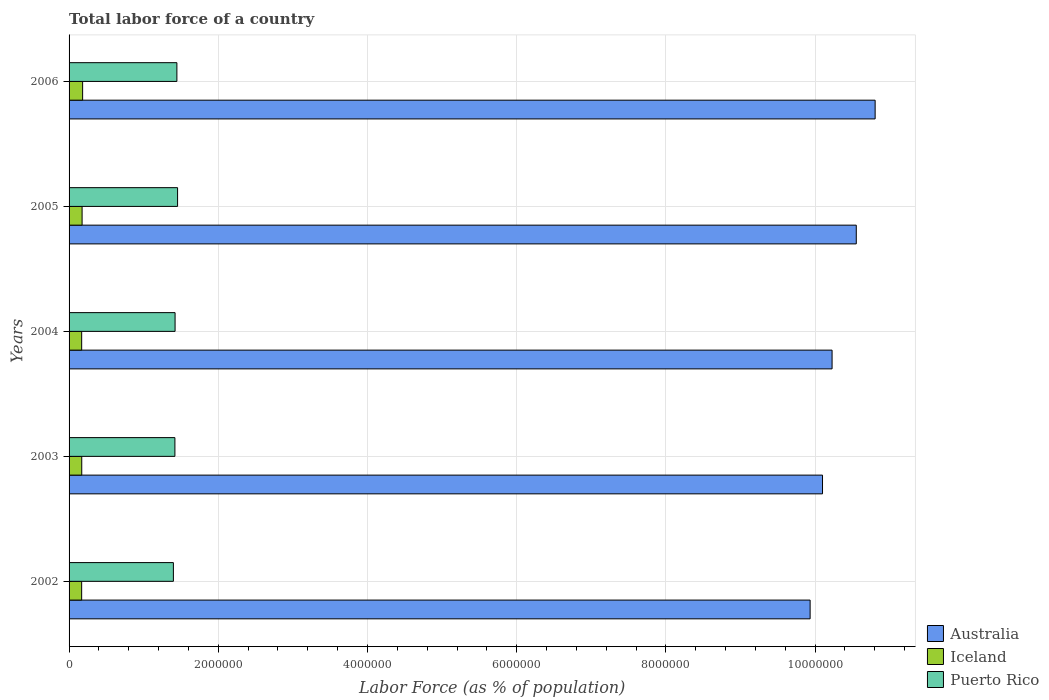How many different coloured bars are there?
Provide a short and direct response. 3. How many groups of bars are there?
Your answer should be very brief. 5. Are the number of bars per tick equal to the number of legend labels?
Give a very brief answer. Yes. How many bars are there on the 4th tick from the bottom?
Your answer should be very brief. 3. In how many cases, is the number of bars for a given year not equal to the number of legend labels?
Offer a terse response. 0. What is the percentage of labor force in Australia in 2004?
Provide a succinct answer. 1.02e+07. Across all years, what is the maximum percentage of labor force in Australia?
Give a very brief answer. 1.08e+07. Across all years, what is the minimum percentage of labor force in Iceland?
Provide a succinct answer. 1.69e+05. In which year was the percentage of labor force in Puerto Rico maximum?
Your response must be concise. 2005. What is the total percentage of labor force in Puerto Rico in the graph?
Your response must be concise. 7.14e+06. What is the difference between the percentage of labor force in Iceland in 2004 and that in 2006?
Your answer should be very brief. -1.29e+04. What is the difference between the percentage of labor force in Puerto Rico in 2005 and the percentage of labor force in Iceland in 2002?
Ensure brevity in your answer.  1.29e+06. What is the average percentage of labor force in Puerto Rico per year?
Your answer should be very brief. 1.43e+06. In the year 2004, what is the difference between the percentage of labor force in Iceland and percentage of labor force in Australia?
Your answer should be compact. -1.01e+07. In how many years, is the percentage of labor force in Iceland greater than 8800000 %?
Offer a terse response. 0. What is the ratio of the percentage of labor force in Puerto Rico in 2004 to that in 2005?
Your answer should be very brief. 0.98. Is the percentage of labor force in Australia in 2003 less than that in 2004?
Offer a very short reply. Yes. What is the difference between the highest and the second highest percentage of labor force in Australia?
Ensure brevity in your answer.  2.53e+05. What is the difference between the highest and the lowest percentage of labor force in Australia?
Your answer should be very brief. 8.71e+05. In how many years, is the percentage of labor force in Puerto Rico greater than the average percentage of labor force in Puerto Rico taken over all years?
Offer a very short reply. 2. What does the 1st bar from the top in 2005 represents?
Provide a succinct answer. Puerto Rico. What does the 3rd bar from the bottom in 2002 represents?
Keep it short and to the point. Puerto Rico. How many years are there in the graph?
Your answer should be very brief. 5. What is the difference between two consecutive major ticks on the X-axis?
Provide a succinct answer. 2.00e+06. Are the values on the major ticks of X-axis written in scientific E-notation?
Ensure brevity in your answer.  No. Where does the legend appear in the graph?
Provide a succinct answer. Bottom right. How are the legend labels stacked?
Provide a short and direct response. Vertical. What is the title of the graph?
Provide a succinct answer. Total labor force of a country. Does "United Kingdom" appear as one of the legend labels in the graph?
Offer a terse response. No. What is the label or title of the X-axis?
Offer a very short reply. Labor Force (as % of population). What is the label or title of the Y-axis?
Ensure brevity in your answer.  Years. What is the Labor Force (as % of population) of Australia in 2002?
Provide a succinct answer. 9.93e+06. What is the Labor Force (as % of population) of Iceland in 2002?
Your answer should be very brief. 1.69e+05. What is the Labor Force (as % of population) of Puerto Rico in 2002?
Make the answer very short. 1.40e+06. What is the Labor Force (as % of population) of Australia in 2003?
Offer a terse response. 1.01e+07. What is the Labor Force (as % of population) of Iceland in 2003?
Keep it short and to the point. 1.70e+05. What is the Labor Force (as % of population) of Puerto Rico in 2003?
Make the answer very short. 1.42e+06. What is the Labor Force (as % of population) in Australia in 2004?
Give a very brief answer. 1.02e+07. What is the Labor Force (as % of population) of Iceland in 2004?
Provide a short and direct response. 1.69e+05. What is the Labor Force (as % of population) of Puerto Rico in 2004?
Make the answer very short. 1.42e+06. What is the Labor Force (as % of population) of Australia in 2005?
Ensure brevity in your answer.  1.06e+07. What is the Labor Force (as % of population) in Iceland in 2005?
Your answer should be compact. 1.75e+05. What is the Labor Force (as % of population) in Puerto Rico in 2005?
Make the answer very short. 1.45e+06. What is the Labor Force (as % of population) of Australia in 2006?
Offer a terse response. 1.08e+07. What is the Labor Force (as % of population) in Iceland in 2006?
Give a very brief answer. 1.82e+05. What is the Labor Force (as % of population) in Puerto Rico in 2006?
Keep it short and to the point. 1.45e+06. Across all years, what is the maximum Labor Force (as % of population) in Australia?
Your answer should be very brief. 1.08e+07. Across all years, what is the maximum Labor Force (as % of population) of Iceland?
Your answer should be compact. 1.82e+05. Across all years, what is the maximum Labor Force (as % of population) in Puerto Rico?
Offer a terse response. 1.45e+06. Across all years, what is the minimum Labor Force (as % of population) of Australia?
Ensure brevity in your answer.  9.93e+06. Across all years, what is the minimum Labor Force (as % of population) of Iceland?
Offer a very short reply. 1.69e+05. Across all years, what is the minimum Labor Force (as % of population) in Puerto Rico?
Your answer should be compact. 1.40e+06. What is the total Labor Force (as % of population) in Australia in the graph?
Keep it short and to the point. 5.16e+07. What is the total Labor Force (as % of population) in Iceland in the graph?
Provide a short and direct response. 8.64e+05. What is the total Labor Force (as % of population) of Puerto Rico in the graph?
Provide a short and direct response. 7.14e+06. What is the difference between the Labor Force (as % of population) of Australia in 2002 and that in 2003?
Your answer should be compact. -1.66e+05. What is the difference between the Labor Force (as % of population) of Iceland in 2002 and that in 2003?
Give a very brief answer. -1405. What is the difference between the Labor Force (as % of population) in Puerto Rico in 2002 and that in 2003?
Provide a short and direct response. -2.03e+04. What is the difference between the Labor Force (as % of population) of Australia in 2002 and that in 2004?
Provide a succinct answer. -2.94e+05. What is the difference between the Labor Force (as % of population) of Iceland in 2002 and that in 2004?
Offer a terse response. -228. What is the difference between the Labor Force (as % of population) of Puerto Rico in 2002 and that in 2004?
Your response must be concise. -2.27e+04. What is the difference between the Labor Force (as % of population) of Australia in 2002 and that in 2005?
Your answer should be very brief. -6.19e+05. What is the difference between the Labor Force (as % of population) of Iceland in 2002 and that in 2005?
Ensure brevity in your answer.  -6024. What is the difference between the Labor Force (as % of population) of Puerto Rico in 2002 and that in 2005?
Provide a short and direct response. -5.61e+04. What is the difference between the Labor Force (as % of population) in Australia in 2002 and that in 2006?
Give a very brief answer. -8.71e+05. What is the difference between the Labor Force (as % of population) in Iceland in 2002 and that in 2006?
Your answer should be very brief. -1.31e+04. What is the difference between the Labor Force (as % of population) of Puerto Rico in 2002 and that in 2006?
Provide a succinct answer. -4.69e+04. What is the difference between the Labor Force (as % of population) of Australia in 2003 and that in 2004?
Make the answer very short. -1.28e+05. What is the difference between the Labor Force (as % of population) in Iceland in 2003 and that in 2004?
Your answer should be compact. 1177. What is the difference between the Labor Force (as % of population) of Puerto Rico in 2003 and that in 2004?
Keep it short and to the point. -2427. What is the difference between the Labor Force (as % of population) in Australia in 2003 and that in 2005?
Keep it short and to the point. -4.53e+05. What is the difference between the Labor Force (as % of population) of Iceland in 2003 and that in 2005?
Give a very brief answer. -4619. What is the difference between the Labor Force (as % of population) in Puerto Rico in 2003 and that in 2005?
Make the answer very short. -3.58e+04. What is the difference between the Labor Force (as % of population) of Australia in 2003 and that in 2006?
Make the answer very short. -7.05e+05. What is the difference between the Labor Force (as % of population) in Iceland in 2003 and that in 2006?
Provide a short and direct response. -1.17e+04. What is the difference between the Labor Force (as % of population) of Puerto Rico in 2003 and that in 2006?
Provide a succinct answer. -2.66e+04. What is the difference between the Labor Force (as % of population) in Australia in 2004 and that in 2005?
Offer a terse response. -3.24e+05. What is the difference between the Labor Force (as % of population) of Iceland in 2004 and that in 2005?
Offer a very short reply. -5796. What is the difference between the Labor Force (as % of population) in Puerto Rico in 2004 and that in 2005?
Ensure brevity in your answer.  -3.34e+04. What is the difference between the Labor Force (as % of population) in Australia in 2004 and that in 2006?
Provide a succinct answer. -5.77e+05. What is the difference between the Labor Force (as % of population) of Iceland in 2004 and that in 2006?
Your answer should be compact. -1.29e+04. What is the difference between the Labor Force (as % of population) of Puerto Rico in 2004 and that in 2006?
Give a very brief answer. -2.42e+04. What is the difference between the Labor Force (as % of population) of Australia in 2005 and that in 2006?
Offer a terse response. -2.53e+05. What is the difference between the Labor Force (as % of population) in Iceland in 2005 and that in 2006?
Provide a short and direct response. -7066. What is the difference between the Labor Force (as % of population) of Puerto Rico in 2005 and that in 2006?
Offer a very short reply. 9212. What is the difference between the Labor Force (as % of population) in Australia in 2002 and the Labor Force (as % of population) in Iceland in 2003?
Provide a short and direct response. 9.76e+06. What is the difference between the Labor Force (as % of population) in Australia in 2002 and the Labor Force (as % of population) in Puerto Rico in 2003?
Make the answer very short. 8.51e+06. What is the difference between the Labor Force (as % of population) of Iceland in 2002 and the Labor Force (as % of population) of Puerto Rico in 2003?
Give a very brief answer. -1.25e+06. What is the difference between the Labor Force (as % of population) of Australia in 2002 and the Labor Force (as % of population) of Iceland in 2004?
Keep it short and to the point. 9.76e+06. What is the difference between the Labor Force (as % of population) of Australia in 2002 and the Labor Force (as % of population) of Puerto Rico in 2004?
Provide a short and direct response. 8.51e+06. What is the difference between the Labor Force (as % of population) of Iceland in 2002 and the Labor Force (as % of population) of Puerto Rico in 2004?
Your response must be concise. -1.25e+06. What is the difference between the Labor Force (as % of population) in Australia in 2002 and the Labor Force (as % of population) in Iceland in 2005?
Offer a very short reply. 9.76e+06. What is the difference between the Labor Force (as % of population) of Australia in 2002 and the Labor Force (as % of population) of Puerto Rico in 2005?
Provide a short and direct response. 8.48e+06. What is the difference between the Labor Force (as % of population) in Iceland in 2002 and the Labor Force (as % of population) in Puerto Rico in 2005?
Make the answer very short. -1.29e+06. What is the difference between the Labor Force (as % of population) of Australia in 2002 and the Labor Force (as % of population) of Iceland in 2006?
Offer a terse response. 9.75e+06. What is the difference between the Labor Force (as % of population) of Australia in 2002 and the Labor Force (as % of population) of Puerto Rico in 2006?
Make the answer very short. 8.49e+06. What is the difference between the Labor Force (as % of population) of Iceland in 2002 and the Labor Force (as % of population) of Puerto Rico in 2006?
Your response must be concise. -1.28e+06. What is the difference between the Labor Force (as % of population) of Australia in 2003 and the Labor Force (as % of population) of Iceland in 2004?
Provide a short and direct response. 9.93e+06. What is the difference between the Labor Force (as % of population) of Australia in 2003 and the Labor Force (as % of population) of Puerto Rico in 2004?
Your answer should be very brief. 8.68e+06. What is the difference between the Labor Force (as % of population) of Iceland in 2003 and the Labor Force (as % of population) of Puerto Rico in 2004?
Provide a succinct answer. -1.25e+06. What is the difference between the Labor Force (as % of population) in Australia in 2003 and the Labor Force (as % of population) in Iceland in 2005?
Your answer should be very brief. 9.92e+06. What is the difference between the Labor Force (as % of population) in Australia in 2003 and the Labor Force (as % of population) in Puerto Rico in 2005?
Ensure brevity in your answer.  8.64e+06. What is the difference between the Labor Force (as % of population) of Iceland in 2003 and the Labor Force (as % of population) of Puerto Rico in 2005?
Offer a terse response. -1.28e+06. What is the difference between the Labor Force (as % of population) of Australia in 2003 and the Labor Force (as % of population) of Iceland in 2006?
Offer a very short reply. 9.92e+06. What is the difference between the Labor Force (as % of population) of Australia in 2003 and the Labor Force (as % of population) of Puerto Rico in 2006?
Provide a succinct answer. 8.65e+06. What is the difference between the Labor Force (as % of population) in Iceland in 2003 and the Labor Force (as % of population) in Puerto Rico in 2006?
Provide a succinct answer. -1.28e+06. What is the difference between the Labor Force (as % of population) in Australia in 2004 and the Labor Force (as % of population) in Iceland in 2005?
Keep it short and to the point. 1.01e+07. What is the difference between the Labor Force (as % of population) of Australia in 2004 and the Labor Force (as % of population) of Puerto Rico in 2005?
Keep it short and to the point. 8.77e+06. What is the difference between the Labor Force (as % of population) of Iceland in 2004 and the Labor Force (as % of population) of Puerto Rico in 2005?
Provide a short and direct response. -1.29e+06. What is the difference between the Labor Force (as % of population) of Australia in 2004 and the Labor Force (as % of population) of Iceland in 2006?
Provide a succinct answer. 1.00e+07. What is the difference between the Labor Force (as % of population) of Australia in 2004 and the Labor Force (as % of population) of Puerto Rico in 2006?
Offer a terse response. 8.78e+06. What is the difference between the Labor Force (as % of population) of Iceland in 2004 and the Labor Force (as % of population) of Puerto Rico in 2006?
Your answer should be compact. -1.28e+06. What is the difference between the Labor Force (as % of population) of Australia in 2005 and the Labor Force (as % of population) of Iceland in 2006?
Make the answer very short. 1.04e+07. What is the difference between the Labor Force (as % of population) of Australia in 2005 and the Labor Force (as % of population) of Puerto Rico in 2006?
Offer a terse response. 9.11e+06. What is the difference between the Labor Force (as % of population) of Iceland in 2005 and the Labor Force (as % of population) of Puerto Rico in 2006?
Your answer should be very brief. -1.27e+06. What is the average Labor Force (as % of population) of Australia per year?
Your response must be concise. 1.03e+07. What is the average Labor Force (as % of population) of Iceland per year?
Make the answer very short. 1.73e+05. What is the average Labor Force (as % of population) of Puerto Rico per year?
Make the answer very short. 1.43e+06. In the year 2002, what is the difference between the Labor Force (as % of population) in Australia and Labor Force (as % of population) in Iceland?
Keep it short and to the point. 9.76e+06. In the year 2002, what is the difference between the Labor Force (as % of population) in Australia and Labor Force (as % of population) in Puerto Rico?
Your response must be concise. 8.53e+06. In the year 2002, what is the difference between the Labor Force (as % of population) of Iceland and Labor Force (as % of population) of Puerto Rico?
Your answer should be very brief. -1.23e+06. In the year 2003, what is the difference between the Labor Force (as % of population) in Australia and Labor Force (as % of population) in Iceland?
Your answer should be compact. 9.93e+06. In the year 2003, what is the difference between the Labor Force (as % of population) of Australia and Labor Force (as % of population) of Puerto Rico?
Offer a very short reply. 8.68e+06. In the year 2003, what is the difference between the Labor Force (as % of population) in Iceland and Labor Force (as % of population) in Puerto Rico?
Keep it short and to the point. -1.25e+06. In the year 2004, what is the difference between the Labor Force (as % of population) of Australia and Labor Force (as % of population) of Iceland?
Give a very brief answer. 1.01e+07. In the year 2004, what is the difference between the Labor Force (as % of population) of Australia and Labor Force (as % of population) of Puerto Rico?
Provide a short and direct response. 8.81e+06. In the year 2004, what is the difference between the Labor Force (as % of population) of Iceland and Labor Force (as % of population) of Puerto Rico?
Give a very brief answer. -1.25e+06. In the year 2005, what is the difference between the Labor Force (as % of population) in Australia and Labor Force (as % of population) in Iceland?
Offer a very short reply. 1.04e+07. In the year 2005, what is the difference between the Labor Force (as % of population) of Australia and Labor Force (as % of population) of Puerto Rico?
Give a very brief answer. 9.10e+06. In the year 2005, what is the difference between the Labor Force (as % of population) of Iceland and Labor Force (as % of population) of Puerto Rico?
Your response must be concise. -1.28e+06. In the year 2006, what is the difference between the Labor Force (as % of population) of Australia and Labor Force (as % of population) of Iceland?
Provide a short and direct response. 1.06e+07. In the year 2006, what is the difference between the Labor Force (as % of population) of Australia and Labor Force (as % of population) of Puerto Rico?
Offer a very short reply. 9.36e+06. In the year 2006, what is the difference between the Labor Force (as % of population) in Iceland and Labor Force (as % of population) in Puerto Rico?
Offer a very short reply. -1.26e+06. What is the ratio of the Labor Force (as % of population) of Australia in 2002 to that in 2003?
Offer a terse response. 0.98. What is the ratio of the Labor Force (as % of population) in Iceland in 2002 to that in 2003?
Make the answer very short. 0.99. What is the ratio of the Labor Force (as % of population) in Puerto Rico in 2002 to that in 2003?
Provide a succinct answer. 0.99. What is the ratio of the Labor Force (as % of population) in Australia in 2002 to that in 2004?
Offer a terse response. 0.97. What is the ratio of the Labor Force (as % of population) in Iceland in 2002 to that in 2004?
Offer a terse response. 1. What is the ratio of the Labor Force (as % of population) in Australia in 2002 to that in 2005?
Give a very brief answer. 0.94. What is the ratio of the Labor Force (as % of population) in Iceland in 2002 to that in 2005?
Offer a terse response. 0.97. What is the ratio of the Labor Force (as % of population) of Puerto Rico in 2002 to that in 2005?
Your answer should be compact. 0.96. What is the ratio of the Labor Force (as % of population) of Australia in 2002 to that in 2006?
Offer a very short reply. 0.92. What is the ratio of the Labor Force (as % of population) of Iceland in 2002 to that in 2006?
Provide a short and direct response. 0.93. What is the ratio of the Labor Force (as % of population) of Puerto Rico in 2002 to that in 2006?
Your answer should be very brief. 0.97. What is the ratio of the Labor Force (as % of population) in Australia in 2003 to that in 2004?
Give a very brief answer. 0.99. What is the ratio of the Labor Force (as % of population) in Puerto Rico in 2003 to that in 2004?
Provide a short and direct response. 1. What is the ratio of the Labor Force (as % of population) of Australia in 2003 to that in 2005?
Ensure brevity in your answer.  0.96. What is the ratio of the Labor Force (as % of population) of Iceland in 2003 to that in 2005?
Ensure brevity in your answer.  0.97. What is the ratio of the Labor Force (as % of population) in Puerto Rico in 2003 to that in 2005?
Provide a short and direct response. 0.98. What is the ratio of the Labor Force (as % of population) in Australia in 2003 to that in 2006?
Keep it short and to the point. 0.93. What is the ratio of the Labor Force (as % of population) of Iceland in 2003 to that in 2006?
Offer a very short reply. 0.94. What is the ratio of the Labor Force (as % of population) of Puerto Rico in 2003 to that in 2006?
Offer a very short reply. 0.98. What is the ratio of the Labor Force (as % of population) of Australia in 2004 to that in 2005?
Your answer should be compact. 0.97. What is the ratio of the Labor Force (as % of population) of Iceland in 2004 to that in 2005?
Make the answer very short. 0.97. What is the ratio of the Labor Force (as % of population) of Puerto Rico in 2004 to that in 2005?
Your answer should be very brief. 0.98. What is the ratio of the Labor Force (as % of population) in Australia in 2004 to that in 2006?
Keep it short and to the point. 0.95. What is the ratio of the Labor Force (as % of population) of Iceland in 2004 to that in 2006?
Your response must be concise. 0.93. What is the ratio of the Labor Force (as % of population) of Puerto Rico in 2004 to that in 2006?
Your answer should be very brief. 0.98. What is the ratio of the Labor Force (as % of population) in Australia in 2005 to that in 2006?
Your answer should be compact. 0.98. What is the ratio of the Labor Force (as % of population) in Iceland in 2005 to that in 2006?
Provide a short and direct response. 0.96. What is the ratio of the Labor Force (as % of population) of Puerto Rico in 2005 to that in 2006?
Give a very brief answer. 1.01. What is the difference between the highest and the second highest Labor Force (as % of population) of Australia?
Your answer should be compact. 2.53e+05. What is the difference between the highest and the second highest Labor Force (as % of population) in Iceland?
Offer a terse response. 7066. What is the difference between the highest and the second highest Labor Force (as % of population) of Puerto Rico?
Your response must be concise. 9212. What is the difference between the highest and the lowest Labor Force (as % of population) in Australia?
Give a very brief answer. 8.71e+05. What is the difference between the highest and the lowest Labor Force (as % of population) in Iceland?
Keep it short and to the point. 1.31e+04. What is the difference between the highest and the lowest Labor Force (as % of population) of Puerto Rico?
Ensure brevity in your answer.  5.61e+04. 